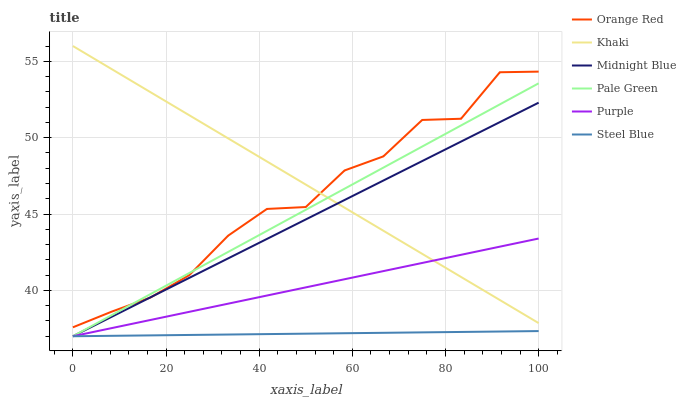Does Steel Blue have the minimum area under the curve?
Answer yes or no. Yes. Does Khaki have the maximum area under the curve?
Answer yes or no. Yes. Does Midnight Blue have the minimum area under the curve?
Answer yes or no. No. Does Midnight Blue have the maximum area under the curve?
Answer yes or no. No. Is Steel Blue the smoothest?
Answer yes or no. Yes. Is Orange Red the roughest?
Answer yes or no. Yes. Is Midnight Blue the smoothest?
Answer yes or no. No. Is Midnight Blue the roughest?
Answer yes or no. No. Does Orange Red have the lowest value?
Answer yes or no. No. Does Khaki have the highest value?
Answer yes or no. Yes. Does Midnight Blue have the highest value?
Answer yes or no. No. Is Steel Blue less than Khaki?
Answer yes or no. Yes. Is Orange Red greater than Purple?
Answer yes or no. Yes. Does Midnight Blue intersect Purple?
Answer yes or no. Yes. Is Midnight Blue less than Purple?
Answer yes or no. No. Is Midnight Blue greater than Purple?
Answer yes or no. No. Does Steel Blue intersect Khaki?
Answer yes or no. No. 